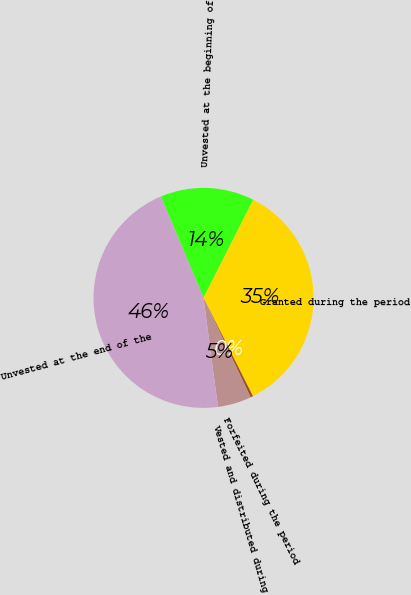<chart> <loc_0><loc_0><loc_500><loc_500><pie_chart><fcel>Unvested at the beginning of<fcel>Granted during the period<fcel>Forfeited during the period<fcel>Vested and distributed during<fcel>Unvested at the end of the<nl><fcel>13.81%<fcel>35.11%<fcel>0.39%<fcel>4.93%<fcel>45.76%<nl></chart> 